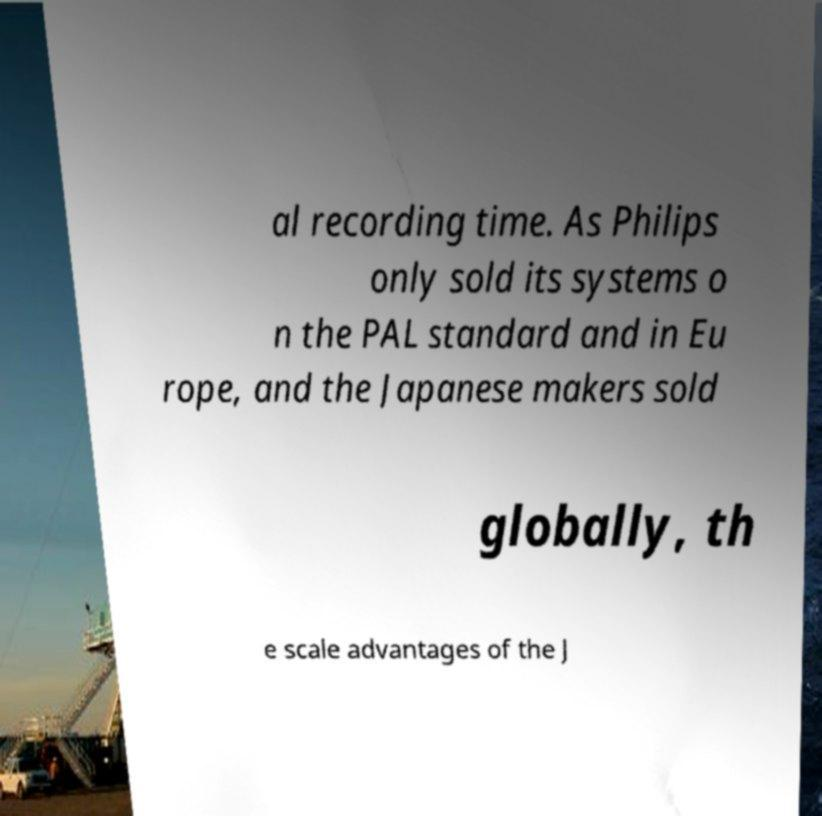Can you read and provide the text displayed in the image?This photo seems to have some interesting text. Can you extract and type it out for me? al recording time. As Philips only sold its systems o n the PAL standard and in Eu rope, and the Japanese makers sold globally, th e scale advantages of the J 